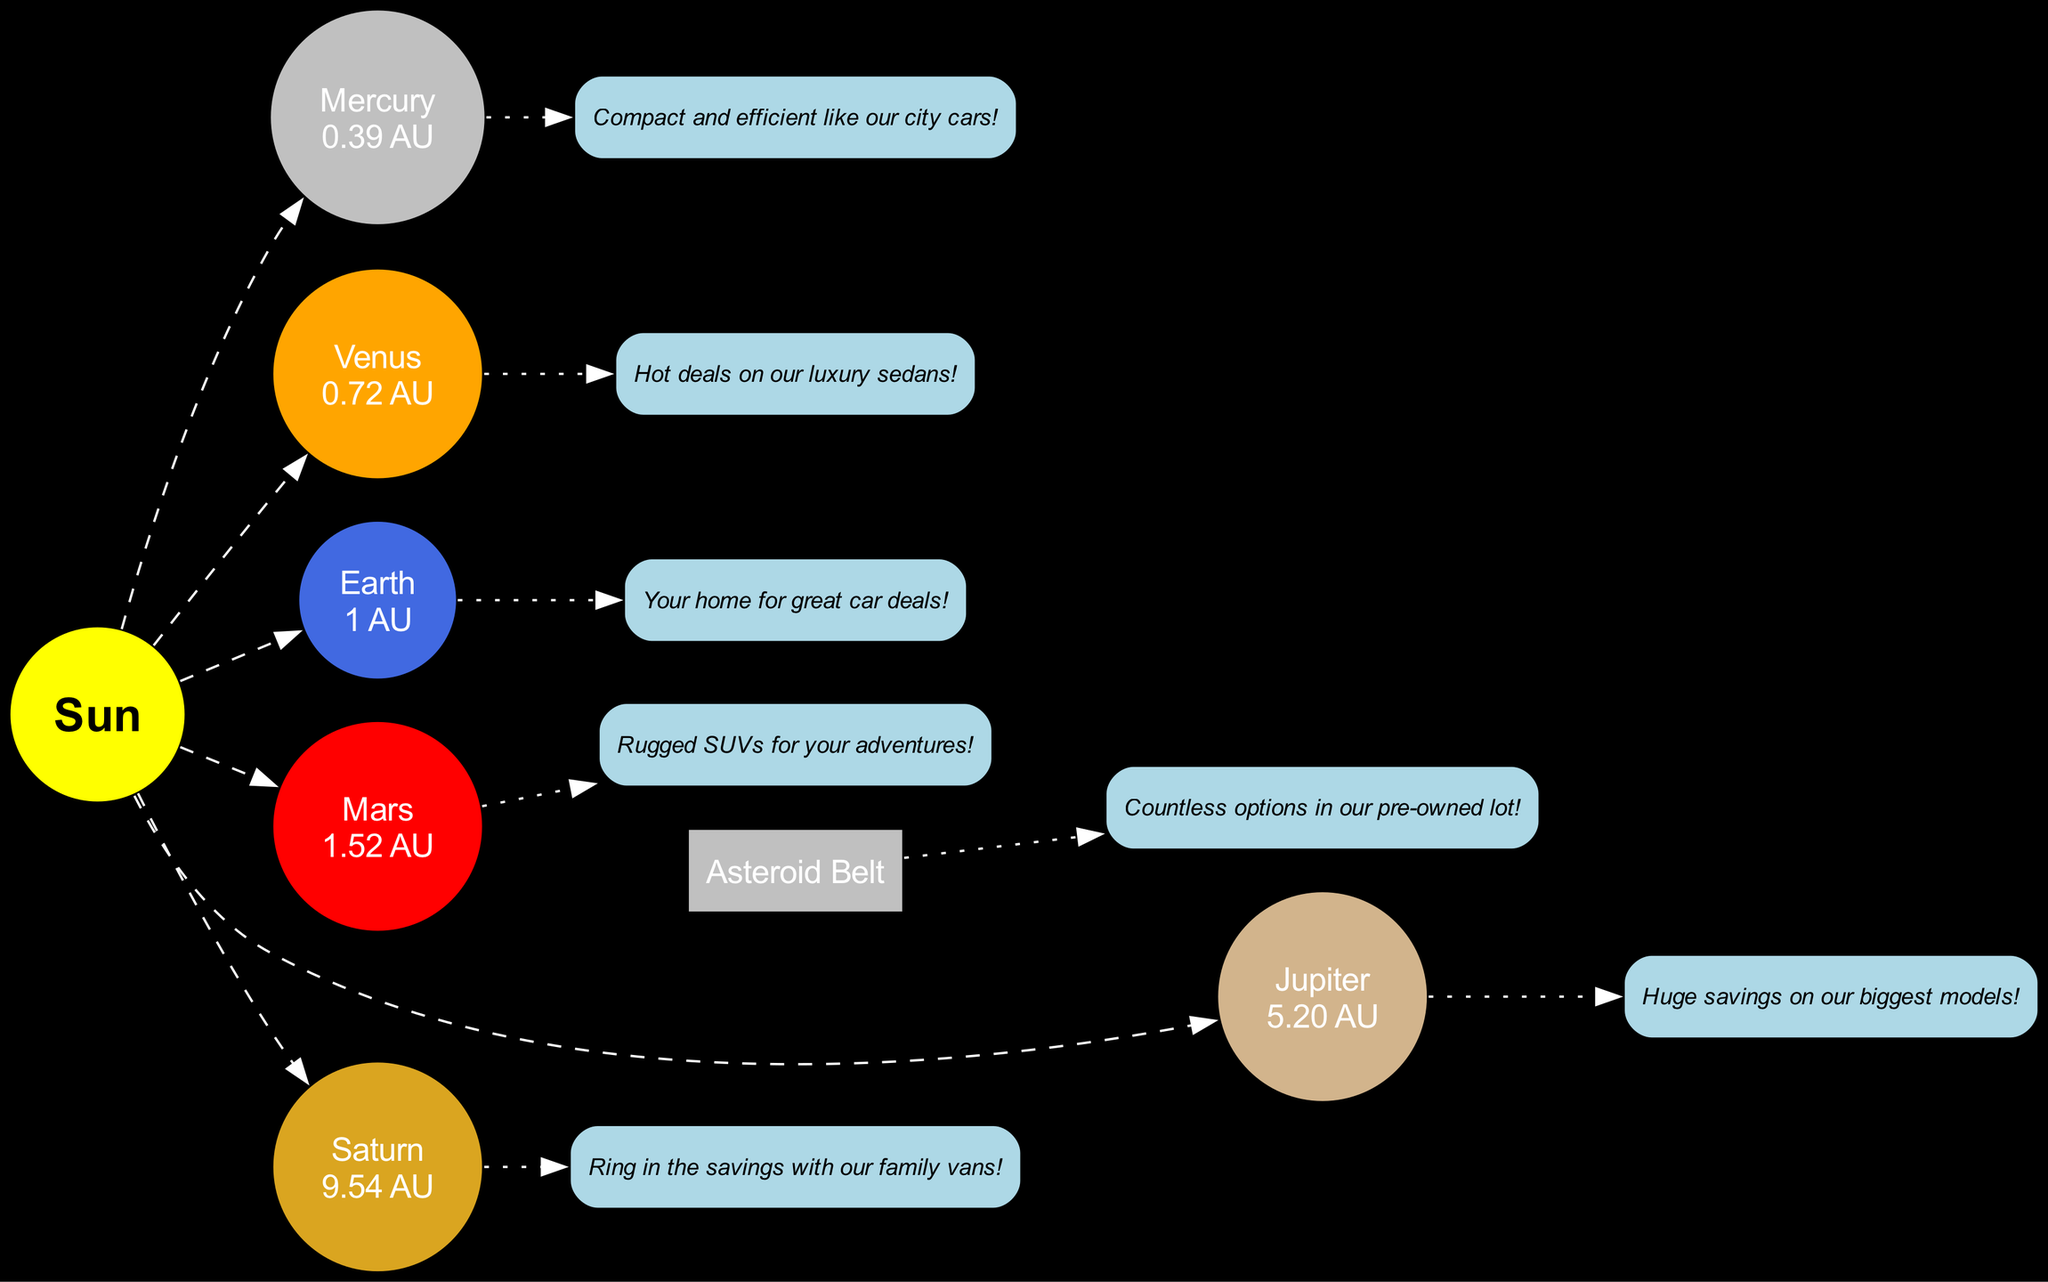What is the distance of Mars from the Sun? The distance of Mars is given directly in the diagram as "1.52 AU."
Answer: 1.52 AU How many planets are shown in the diagram? The diagram lists six planets: Mercury, Venus, Earth, Mars, Jupiter, and Saturn. Therefore, the total count of planets is 6.
Answer: 6 What is the slogan associated with Jupiter? The slogan for Jupiter is stated in the diagram as "Huge savings on our biggest models!"
Answer: Huge savings on our biggest models! What is the position of the Asteroid Belt relative to the planets? The Asteroid Belt is situated between Mars and Jupiter, according to the diagram. Thus, the relationship can be described as being located in between those two planets.
Answer: Between Mars and Jupiter Which planet has the slogan "Your home for great car deals!"? The slogan is specifically associated with Earth, as indicated in the diagram, thus answering the question is straightforward.
Answer: Earth How many edges are linking the Sun to the planets? There are six planets connected to the Sun by dashed edges; hence the total number of edges from the Sun to the planets is 6.
Answer: 6 Which planet is closest to the Sun? Based on the distances listed in the diagram, Mercury, at a distance of "0.39 AU," is confirmed as the closest planet to the Sun.
Answer: Mercury What is the color of the planet Venus in the diagram? The diagram identifies Venus with the color orange specifically, which is defined in the node attributes.
Answer: Orange What type of vehicles does the slogan for Mars suggest? The slogan for Mars reads "Rugged SUVs for your adventures!" which indicates the type of vehicles suggested are SUVs.
Answer: SUVs 